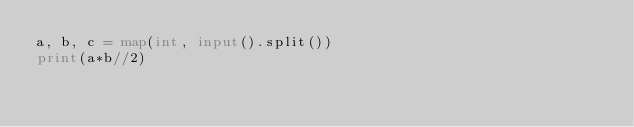Convert code to text. <code><loc_0><loc_0><loc_500><loc_500><_Python_>a, b, c = map(int, input().split())
print(a*b//2)</code> 